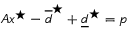Convert formula to latex. <formula><loc_0><loc_0><loc_500><loc_500>A x ^ { ^ { * } } - \overline { d } ^ { ^ { * } } + \underline { d } ^ { ^ { * } } = p</formula> 